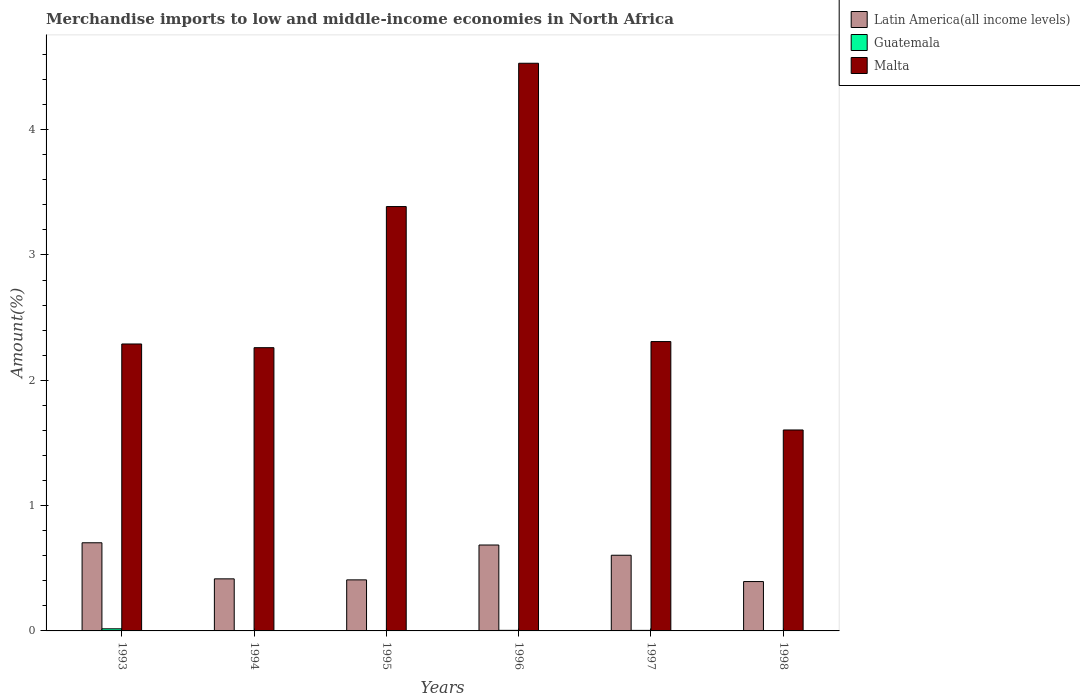How many groups of bars are there?
Keep it short and to the point. 6. How many bars are there on the 4th tick from the right?
Provide a succinct answer. 3. What is the label of the 6th group of bars from the left?
Ensure brevity in your answer.  1998. What is the percentage of amount earned from merchandise imports in Malta in 1995?
Offer a terse response. 3.39. Across all years, what is the maximum percentage of amount earned from merchandise imports in Guatemala?
Ensure brevity in your answer.  0.02. Across all years, what is the minimum percentage of amount earned from merchandise imports in Guatemala?
Make the answer very short. 0. In which year was the percentage of amount earned from merchandise imports in Latin America(all income levels) minimum?
Ensure brevity in your answer.  1998. What is the total percentage of amount earned from merchandise imports in Malta in the graph?
Keep it short and to the point. 16.38. What is the difference between the percentage of amount earned from merchandise imports in Guatemala in 1993 and that in 1997?
Your response must be concise. 0.01. What is the difference between the percentage of amount earned from merchandise imports in Guatemala in 1997 and the percentage of amount earned from merchandise imports in Latin America(all income levels) in 1996?
Offer a very short reply. -0.68. What is the average percentage of amount earned from merchandise imports in Malta per year?
Provide a short and direct response. 2.73. In the year 1995, what is the difference between the percentage of amount earned from merchandise imports in Malta and percentage of amount earned from merchandise imports in Guatemala?
Keep it short and to the point. 3.39. In how many years, is the percentage of amount earned from merchandise imports in Guatemala greater than 2.2 %?
Your answer should be compact. 0. What is the ratio of the percentage of amount earned from merchandise imports in Guatemala in 1995 to that in 1998?
Offer a very short reply. 0.54. What is the difference between the highest and the second highest percentage of amount earned from merchandise imports in Guatemala?
Ensure brevity in your answer.  0.01. What is the difference between the highest and the lowest percentage of amount earned from merchandise imports in Latin America(all income levels)?
Your response must be concise. 0.31. In how many years, is the percentage of amount earned from merchandise imports in Latin America(all income levels) greater than the average percentage of amount earned from merchandise imports in Latin America(all income levels) taken over all years?
Offer a terse response. 3. What does the 3rd bar from the left in 1996 represents?
Ensure brevity in your answer.  Malta. What does the 3rd bar from the right in 1993 represents?
Give a very brief answer. Latin America(all income levels). Is it the case that in every year, the sum of the percentage of amount earned from merchandise imports in Guatemala and percentage of amount earned from merchandise imports in Latin America(all income levels) is greater than the percentage of amount earned from merchandise imports in Malta?
Offer a very short reply. No. How many bars are there?
Offer a terse response. 18. What is the difference between two consecutive major ticks on the Y-axis?
Your response must be concise. 1. Are the values on the major ticks of Y-axis written in scientific E-notation?
Your answer should be very brief. No. Where does the legend appear in the graph?
Offer a terse response. Top right. How many legend labels are there?
Provide a short and direct response. 3. What is the title of the graph?
Your response must be concise. Merchandise imports to low and middle-income economies in North Africa. What is the label or title of the X-axis?
Make the answer very short. Years. What is the label or title of the Y-axis?
Offer a very short reply. Amount(%). What is the Amount(%) in Latin America(all income levels) in 1993?
Your response must be concise. 0.7. What is the Amount(%) in Guatemala in 1993?
Ensure brevity in your answer.  0.02. What is the Amount(%) of Malta in 1993?
Keep it short and to the point. 2.29. What is the Amount(%) of Latin America(all income levels) in 1994?
Offer a very short reply. 0.42. What is the Amount(%) of Guatemala in 1994?
Provide a short and direct response. 0. What is the Amount(%) in Malta in 1994?
Give a very brief answer. 2.26. What is the Amount(%) of Latin America(all income levels) in 1995?
Your response must be concise. 0.41. What is the Amount(%) of Guatemala in 1995?
Ensure brevity in your answer.  0. What is the Amount(%) in Malta in 1995?
Provide a succinct answer. 3.39. What is the Amount(%) in Latin America(all income levels) in 1996?
Keep it short and to the point. 0.69. What is the Amount(%) in Guatemala in 1996?
Your answer should be compact. 0. What is the Amount(%) in Malta in 1996?
Ensure brevity in your answer.  4.53. What is the Amount(%) in Latin America(all income levels) in 1997?
Keep it short and to the point. 0.6. What is the Amount(%) of Guatemala in 1997?
Your answer should be very brief. 0. What is the Amount(%) of Malta in 1997?
Your response must be concise. 2.31. What is the Amount(%) of Latin America(all income levels) in 1998?
Offer a terse response. 0.39. What is the Amount(%) in Guatemala in 1998?
Give a very brief answer. 0. What is the Amount(%) in Malta in 1998?
Offer a terse response. 1.6. Across all years, what is the maximum Amount(%) of Latin America(all income levels)?
Your answer should be very brief. 0.7. Across all years, what is the maximum Amount(%) of Guatemala?
Offer a very short reply. 0.02. Across all years, what is the maximum Amount(%) in Malta?
Offer a very short reply. 4.53. Across all years, what is the minimum Amount(%) in Latin America(all income levels)?
Your answer should be compact. 0.39. Across all years, what is the minimum Amount(%) in Guatemala?
Provide a short and direct response. 0. Across all years, what is the minimum Amount(%) in Malta?
Provide a succinct answer. 1.6. What is the total Amount(%) of Latin America(all income levels) in the graph?
Provide a succinct answer. 3.21. What is the total Amount(%) of Guatemala in the graph?
Make the answer very short. 0.03. What is the total Amount(%) in Malta in the graph?
Your answer should be compact. 16.38. What is the difference between the Amount(%) of Latin America(all income levels) in 1993 and that in 1994?
Provide a short and direct response. 0.29. What is the difference between the Amount(%) in Guatemala in 1993 and that in 1994?
Give a very brief answer. 0.02. What is the difference between the Amount(%) of Malta in 1993 and that in 1994?
Ensure brevity in your answer.  0.03. What is the difference between the Amount(%) in Latin America(all income levels) in 1993 and that in 1995?
Your response must be concise. 0.3. What is the difference between the Amount(%) in Guatemala in 1993 and that in 1995?
Offer a terse response. 0.02. What is the difference between the Amount(%) of Malta in 1993 and that in 1995?
Ensure brevity in your answer.  -1.1. What is the difference between the Amount(%) in Latin America(all income levels) in 1993 and that in 1996?
Ensure brevity in your answer.  0.02. What is the difference between the Amount(%) in Guatemala in 1993 and that in 1996?
Your response must be concise. 0.01. What is the difference between the Amount(%) in Malta in 1993 and that in 1996?
Keep it short and to the point. -2.24. What is the difference between the Amount(%) in Latin America(all income levels) in 1993 and that in 1997?
Keep it short and to the point. 0.1. What is the difference between the Amount(%) of Guatemala in 1993 and that in 1997?
Offer a terse response. 0.01. What is the difference between the Amount(%) of Malta in 1993 and that in 1997?
Your response must be concise. -0.02. What is the difference between the Amount(%) in Latin America(all income levels) in 1993 and that in 1998?
Your answer should be compact. 0.31. What is the difference between the Amount(%) in Guatemala in 1993 and that in 1998?
Provide a succinct answer. 0.02. What is the difference between the Amount(%) in Malta in 1993 and that in 1998?
Offer a very short reply. 0.69. What is the difference between the Amount(%) of Latin America(all income levels) in 1994 and that in 1995?
Your response must be concise. 0.01. What is the difference between the Amount(%) of Malta in 1994 and that in 1995?
Your answer should be very brief. -1.13. What is the difference between the Amount(%) of Latin America(all income levels) in 1994 and that in 1996?
Give a very brief answer. -0.27. What is the difference between the Amount(%) in Guatemala in 1994 and that in 1996?
Keep it short and to the point. -0. What is the difference between the Amount(%) in Malta in 1994 and that in 1996?
Offer a very short reply. -2.27. What is the difference between the Amount(%) of Latin America(all income levels) in 1994 and that in 1997?
Your answer should be very brief. -0.19. What is the difference between the Amount(%) of Guatemala in 1994 and that in 1997?
Your answer should be compact. -0. What is the difference between the Amount(%) of Malta in 1994 and that in 1997?
Your answer should be compact. -0.05. What is the difference between the Amount(%) in Latin America(all income levels) in 1994 and that in 1998?
Provide a short and direct response. 0.02. What is the difference between the Amount(%) in Guatemala in 1994 and that in 1998?
Your answer should be compact. -0. What is the difference between the Amount(%) of Malta in 1994 and that in 1998?
Offer a very short reply. 0.66. What is the difference between the Amount(%) of Latin America(all income levels) in 1995 and that in 1996?
Keep it short and to the point. -0.28. What is the difference between the Amount(%) in Guatemala in 1995 and that in 1996?
Make the answer very short. -0. What is the difference between the Amount(%) in Malta in 1995 and that in 1996?
Provide a short and direct response. -1.14. What is the difference between the Amount(%) in Latin America(all income levels) in 1995 and that in 1997?
Offer a terse response. -0.2. What is the difference between the Amount(%) of Guatemala in 1995 and that in 1997?
Provide a short and direct response. -0. What is the difference between the Amount(%) of Malta in 1995 and that in 1997?
Make the answer very short. 1.08. What is the difference between the Amount(%) in Latin America(all income levels) in 1995 and that in 1998?
Keep it short and to the point. 0.01. What is the difference between the Amount(%) of Guatemala in 1995 and that in 1998?
Your answer should be very brief. -0. What is the difference between the Amount(%) in Malta in 1995 and that in 1998?
Provide a succinct answer. 1.78. What is the difference between the Amount(%) of Latin America(all income levels) in 1996 and that in 1997?
Your answer should be compact. 0.08. What is the difference between the Amount(%) of Guatemala in 1996 and that in 1997?
Offer a terse response. 0. What is the difference between the Amount(%) of Malta in 1996 and that in 1997?
Provide a succinct answer. 2.22. What is the difference between the Amount(%) of Latin America(all income levels) in 1996 and that in 1998?
Provide a succinct answer. 0.29. What is the difference between the Amount(%) in Guatemala in 1996 and that in 1998?
Give a very brief answer. 0. What is the difference between the Amount(%) in Malta in 1996 and that in 1998?
Provide a short and direct response. 2.93. What is the difference between the Amount(%) of Latin America(all income levels) in 1997 and that in 1998?
Offer a terse response. 0.21. What is the difference between the Amount(%) of Guatemala in 1997 and that in 1998?
Make the answer very short. 0. What is the difference between the Amount(%) of Malta in 1997 and that in 1998?
Provide a succinct answer. 0.71. What is the difference between the Amount(%) of Latin America(all income levels) in 1993 and the Amount(%) of Guatemala in 1994?
Your answer should be very brief. 0.7. What is the difference between the Amount(%) of Latin America(all income levels) in 1993 and the Amount(%) of Malta in 1994?
Keep it short and to the point. -1.56. What is the difference between the Amount(%) in Guatemala in 1993 and the Amount(%) in Malta in 1994?
Provide a succinct answer. -2.24. What is the difference between the Amount(%) in Latin America(all income levels) in 1993 and the Amount(%) in Guatemala in 1995?
Keep it short and to the point. 0.7. What is the difference between the Amount(%) in Latin America(all income levels) in 1993 and the Amount(%) in Malta in 1995?
Give a very brief answer. -2.68. What is the difference between the Amount(%) in Guatemala in 1993 and the Amount(%) in Malta in 1995?
Give a very brief answer. -3.37. What is the difference between the Amount(%) of Latin America(all income levels) in 1993 and the Amount(%) of Guatemala in 1996?
Offer a very short reply. 0.7. What is the difference between the Amount(%) in Latin America(all income levels) in 1993 and the Amount(%) in Malta in 1996?
Your response must be concise. -3.83. What is the difference between the Amount(%) in Guatemala in 1993 and the Amount(%) in Malta in 1996?
Offer a very short reply. -4.51. What is the difference between the Amount(%) of Latin America(all income levels) in 1993 and the Amount(%) of Guatemala in 1997?
Give a very brief answer. 0.7. What is the difference between the Amount(%) in Latin America(all income levels) in 1993 and the Amount(%) in Malta in 1997?
Offer a very short reply. -1.61. What is the difference between the Amount(%) in Guatemala in 1993 and the Amount(%) in Malta in 1997?
Your answer should be very brief. -2.29. What is the difference between the Amount(%) of Latin America(all income levels) in 1993 and the Amount(%) of Guatemala in 1998?
Your response must be concise. 0.7. What is the difference between the Amount(%) of Latin America(all income levels) in 1993 and the Amount(%) of Malta in 1998?
Offer a very short reply. -0.9. What is the difference between the Amount(%) of Guatemala in 1993 and the Amount(%) of Malta in 1998?
Your answer should be compact. -1.59. What is the difference between the Amount(%) of Latin America(all income levels) in 1994 and the Amount(%) of Guatemala in 1995?
Offer a terse response. 0.41. What is the difference between the Amount(%) of Latin America(all income levels) in 1994 and the Amount(%) of Malta in 1995?
Ensure brevity in your answer.  -2.97. What is the difference between the Amount(%) in Guatemala in 1994 and the Amount(%) in Malta in 1995?
Give a very brief answer. -3.39. What is the difference between the Amount(%) of Latin America(all income levels) in 1994 and the Amount(%) of Guatemala in 1996?
Provide a short and direct response. 0.41. What is the difference between the Amount(%) of Latin America(all income levels) in 1994 and the Amount(%) of Malta in 1996?
Give a very brief answer. -4.11. What is the difference between the Amount(%) in Guatemala in 1994 and the Amount(%) in Malta in 1996?
Your answer should be compact. -4.53. What is the difference between the Amount(%) of Latin America(all income levels) in 1994 and the Amount(%) of Guatemala in 1997?
Offer a terse response. 0.41. What is the difference between the Amount(%) of Latin America(all income levels) in 1994 and the Amount(%) of Malta in 1997?
Keep it short and to the point. -1.89. What is the difference between the Amount(%) of Guatemala in 1994 and the Amount(%) of Malta in 1997?
Offer a very short reply. -2.31. What is the difference between the Amount(%) in Latin America(all income levels) in 1994 and the Amount(%) in Guatemala in 1998?
Offer a terse response. 0.41. What is the difference between the Amount(%) in Latin America(all income levels) in 1994 and the Amount(%) in Malta in 1998?
Your answer should be compact. -1.19. What is the difference between the Amount(%) of Guatemala in 1994 and the Amount(%) of Malta in 1998?
Keep it short and to the point. -1.6. What is the difference between the Amount(%) of Latin America(all income levels) in 1995 and the Amount(%) of Guatemala in 1996?
Make the answer very short. 0.4. What is the difference between the Amount(%) of Latin America(all income levels) in 1995 and the Amount(%) of Malta in 1996?
Keep it short and to the point. -4.12. What is the difference between the Amount(%) in Guatemala in 1995 and the Amount(%) in Malta in 1996?
Your response must be concise. -4.53. What is the difference between the Amount(%) of Latin America(all income levels) in 1995 and the Amount(%) of Guatemala in 1997?
Make the answer very short. 0.4. What is the difference between the Amount(%) in Latin America(all income levels) in 1995 and the Amount(%) in Malta in 1997?
Keep it short and to the point. -1.9. What is the difference between the Amount(%) of Guatemala in 1995 and the Amount(%) of Malta in 1997?
Give a very brief answer. -2.31. What is the difference between the Amount(%) in Latin America(all income levels) in 1995 and the Amount(%) in Guatemala in 1998?
Make the answer very short. 0.41. What is the difference between the Amount(%) in Latin America(all income levels) in 1995 and the Amount(%) in Malta in 1998?
Ensure brevity in your answer.  -1.2. What is the difference between the Amount(%) in Guatemala in 1995 and the Amount(%) in Malta in 1998?
Your answer should be compact. -1.6. What is the difference between the Amount(%) in Latin America(all income levels) in 1996 and the Amount(%) in Guatemala in 1997?
Your response must be concise. 0.68. What is the difference between the Amount(%) of Latin America(all income levels) in 1996 and the Amount(%) of Malta in 1997?
Offer a terse response. -1.62. What is the difference between the Amount(%) in Guatemala in 1996 and the Amount(%) in Malta in 1997?
Give a very brief answer. -2.3. What is the difference between the Amount(%) of Latin America(all income levels) in 1996 and the Amount(%) of Guatemala in 1998?
Provide a succinct answer. 0.68. What is the difference between the Amount(%) in Latin America(all income levels) in 1996 and the Amount(%) in Malta in 1998?
Ensure brevity in your answer.  -0.92. What is the difference between the Amount(%) of Guatemala in 1996 and the Amount(%) of Malta in 1998?
Your answer should be compact. -1.6. What is the difference between the Amount(%) of Latin America(all income levels) in 1997 and the Amount(%) of Guatemala in 1998?
Offer a terse response. 0.6. What is the difference between the Amount(%) of Latin America(all income levels) in 1997 and the Amount(%) of Malta in 1998?
Make the answer very short. -1. What is the difference between the Amount(%) of Guatemala in 1997 and the Amount(%) of Malta in 1998?
Your answer should be compact. -1.6. What is the average Amount(%) of Latin America(all income levels) per year?
Your answer should be compact. 0.54. What is the average Amount(%) of Guatemala per year?
Keep it short and to the point. 0. What is the average Amount(%) in Malta per year?
Provide a short and direct response. 2.73. In the year 1993, what is the difference between the Amount(%) in Latin America(all income levels) and Amount(%) in Guatemala?
Offer a terse response. 0.69. In the year 1993, what is the difference between the Amount(%) of Latin America(all income levels) and Amount(%) of Malta?
Keep it short and to the point. -1.59. In the year 1993, what is the difference between the Amount(%) of Guatemala and Amount(%) of Malta?
Offer a very short reply. -2.27. In the year 1994, what is the difference between the Amount(%) of Latin America(all income levels) and Amount(%) of Guatemala?
Provide a short and direct response. 0.41. In the year 1994, what is the difference between the Amount(%) in Latin America(all income levels) and Amount(%) in Malta?
Provide a short and direct response. -1.84. In the year 1994, what is the difference between the Amount(%) in Guatemala and Amount(%) in Malta?
Your answer should be compact. -2.26. In the year 1995, what is the difference between the Amount(%) in Latin America(all income levels) and Amount(%) in Guatemala?
Your answer should be compact. 0.41. In the year 1995, what is the difference between the Amount(%) of Latin America(all income levels) and Amount(%) of Malta?
Provide a succinct answer. -2.98. In the year 1995, what is the difference between the Amount(%) of Guatemala and Amount(%) of Malta?
Give a very brief answer. -3.39. In the year 1996, what is the difference between the Amount(%) in Latin America(all income levels) and Amount(%) in Guatemala?
Keep it short and to the point. 0.68. In the year 1996, what is the difference between the Amount(%) in Latin America(all income levels) and Amount(%) in Malta?
Keep it short and to the point. -3.84. In the year 1996, what is the difference between the Amount(%) of Guatemala and Amount(%) of Malta?
Your answer should be compact. -4.53. In the year 1997, what is the difference between the Amount(%) in Latin America(all income levels) and Amount(%) in Guatemala?
Provide a short and direct response. 0.6. In the year 1997, what is the difference between the Amount(%) of Latin America(all income levels) and Amount(%) of Malta?
Make the answer very short. -1.71. In the year 1997, what is the difference between the Amount(%) in Guatemala and Amount(%) in Malta?
Provide a succinct answer. -2.3. In the year 1998, what is the difference between the Amount(%) of Latin America(all income levels) and Amount(%) of Guatemala?
Keep it short and to the point. 0.39. In the year 1998, what is the difference between the Amount(%) of Latin America(all income levels) and Amount(%) of Malta?
Your answer should be compact. -1.21. In the year 1998, what is the difference between the Amount(%) in Guatemala and Amount(%) in Malta?
Provide a short and direct response. -1.6. What is the ratio of the Amount(%) in Latin America(all income levels) in 1993 to that in 1994?
Your answer should be very brief. 1.69. What is the ratio of the Amount(%) in Guatemala in 1993 to that in 1994?
Your response must be concise. 15.77. What is the ratio of the Amount(%) in Latin America(all income levels) in 1993 to that in 1995?
Keep it short and to the point. 1.73. What is the ratio of the Amount(%) in Guatemala in 1993 to that in 1995?
Provide a short and direct response. 21.82. What is the ratio of the Amount(%) of Malta in 1993 to that in 1995?
Your answer should be compact. 0.68. What is the ratio of the Amount(%) of Latin America(all income levels) in 1993 to that in 1996?
Your answer should be very brief. 1.03. What is the ratio of the Amount(%) in Guatemala in 1993 to that in 1996?
Your answer should be very brief. 3.72. What is the ratio of the Amount(%) in Malta in 1993 to that in 1996?
Give a very brief answer. 0.51. What is the ratio of the Amount(%) of Latin America(all income levels) in 1993 to that in 1997?
Offer a very short reply. 1.16. What is the ratio of the Amount(%) of Guatemala in 1993 to that in 1997?
Provide a short and direct response. 3.89. What is the ratio of the Amount(%) in Latin America(all income levels) in 1993 to that in 1998?
Provide a succinct answer. 1.79. What is the ratio of the Amount(%) of Guatemala in 1993 to that in 1998?
Offer a terse response. 11.7. What is the ratio of the Amount(%) of Malta in 1993 to that in 1998?
Your answer should be compact. 1.43. What is the ratio of the Amount(%) in Latin America(all income levels) in 1994 to that in 1995?
Offer a very short reply. 1.02. What is the ratio of the Amount(%) of Guatemala in 1994 to that in 1995?
Your response must be concise. 1.38. What is the ratio of the Amount(%) in Malta in 1994 to that in 1995?
Make the answer very short. 0.67. What is the ratio of the Amount(%) of Latin America(all income levels) in 1994 to that in 1996?
Offer a very short reply. 0.61. What is the ratio of the Amount(%) in Guatemala in 1994 to that in 1996?
Your response must be concise. 0.24. What is the ratio of the Amount(%) of Malta in 1994 to that in 1996?
Ensure brevity in your answer.  0.5. What is the ratio of the Amount(%) in Latin America(all income levels) in 1994 to that in 1997?
Provide a succinct answer. 0.69. What is the ratio of the Amount(%) of Guatemala in 1994 to that in 1997?
Keep it short and to the point. 0.25. What is the ratio of the Amount(%) in Malta in 1994 to that in 1997?
Give a very brief answer. 0.98. What is the ratio of the Amount(%) in Latin America(all income levels) in 1994 to that in 1998?
Your answer should be compact. 1.05. What is the ratio of the Amount(%) in Guatemala in 1994 to that in 1998?
Offer a terse response. 0.74. What is the ratio of the Amount(%) in Malta in 1994 to that in 1998?
Keep it short and to the point. 1.41. What is the ratio of the Amount(%) of Latin America(all income levels) in 1995 to that in 1996?
Ensure brevity in your answer.  0.59. What is the ratio of the Amount(%) in Guatemala in 1995 to that in 1996?
Provide a succinct answer. 0.17. What is the ratio of the Amount(%) in Malta in 1995 to that in 1996?
Your response must be concise. 0.75. What is the ratio of the Amount(%) in Latin America(all income levels) in 1995 to that in 1997?
Keep it short and to the point. 0.67. What is the ratio of the Amount(%) in Guatemala in 1995 to that in 1997?
Provide a short and direct response. 0.18. What is the ratio of the Amount(%) of Malta in 1995 to that in 1997?
Make the answer very short. 1.47. What is the ratio of the Amount(%) of Latin America(all income levels) in 1995 to that in 1998?
Keep it short and to the point. 1.03. What is the ratio of the Amount(%) in Guatemala in 1995 to that in 1998?
Provide a succinct answer. 0.54. What is the ratio of the Amount(%) of Malta in 1995 to that in 1998?
Make the answer very short. 2.11. What is the ratio of the Amount(%) in Latin America(all income levels) in 1996 to that in 1997?
Offer a very short reply. 1.14. What is the ratio of the Amount(%) of Guatemala in 1996 to that in 1997?
Make the answer very short. 1.05. What is the ratio of the Amount(%) in Malta in 1996 to that in 1997?
Offer a terse response. 1.96. What is the ratio of the Amount(%) of Latin America(all income levels) in 1996 to that in 1998?
Make the answer very short. 1.74. What is the ratio of the Amount(%) in Guatemala in 1996 to that in 1998?
Your response must be concise. 3.15. What is the ratio of the Amount(%) of Malta in 1996 to that in 1998?
Offer a very short reply. 2.82. What is the ratio of the Amount(%) of Latin America(all income levels) in 1997 to that in 1998?
Keep it short and to the point. 1.53. What is the ratio of the Amount(%) of Guatemala in 1997 to that in 1998?
Your response must be concise. 3.01. What is the ratio of the Amount(%) of Malta in 1997 to that in 1998?
Your answer should be compact. 1.44. What is the difference between the highest and the second highest Amount(%) of Latin America(all income levels)?
Keep it short and to the point. 0.02. What is the difference between the highest and the second highest Amount(%) of Guatemala?
Provide a short and direct response. 0.01. What is the difference between the highest and the second highest Amount(%) in Malta?
Make the answer very short. 1.14. What is the difference between the highest and the lowest Amount(%) of Latin America(all income levels)?
Your response must be concise. 0.31. What is the difference between the highest and the lowest Amount(%) of Guatemala?
Offer a very short reply. 0.02. What is the difference between the highest and the lowest Amount(%) of Malta?
Make the answer very short. 2.93. 